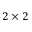<formula> <loc_0><loc_0><loc_500><loc_500>2 \times 2</formula> 